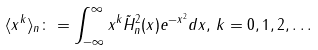Convert formula to latex. <formula><loc_0><loc_0><loc_500><loc_500>\langle x ^ { k } \rangle _ { n } \colon = \int _ { - \infty } ^ { \infty } x ^ { k } \tilde { H } _ { n } ^ { 2 } ( x ) e ^ { - x ^ { 2 } } d x , \, k = 0 , 1 , 2 , \dots</formula> 